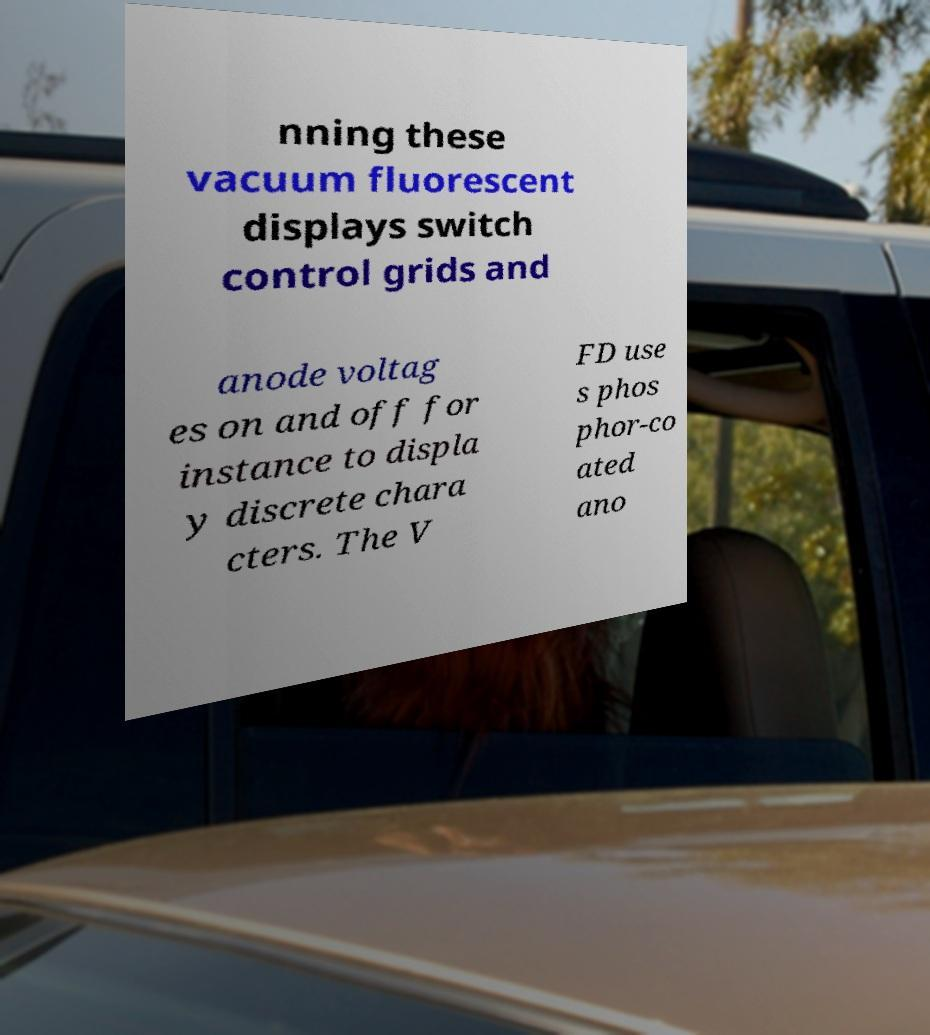Can you read and provide the text displayed in the image?This photo seems to have some interesting text. Can you extract and type it out for me? nning these vacuum fluorescent displays switch control grids and anode voltag es on and off for instance to displa y discrete chara cters. The V FD use s phos phor-co ated ano 